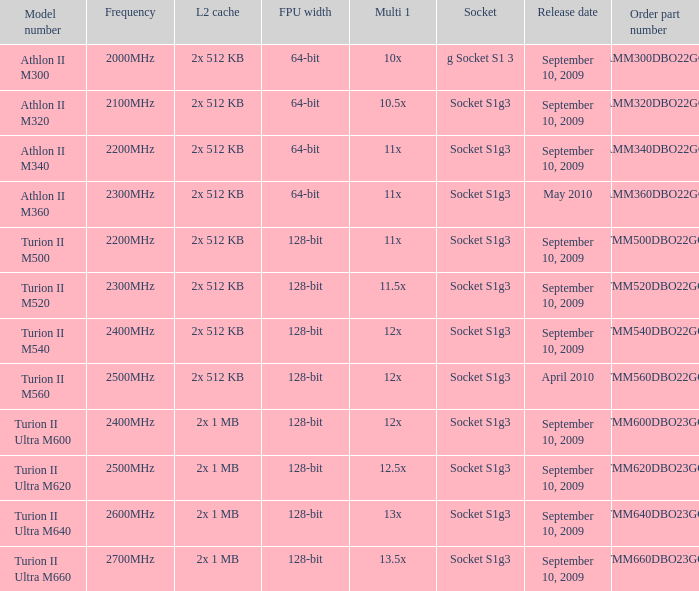What socket has a part number amm300dbo22gq and was released on september 10, 2009? G socket s1 3. 